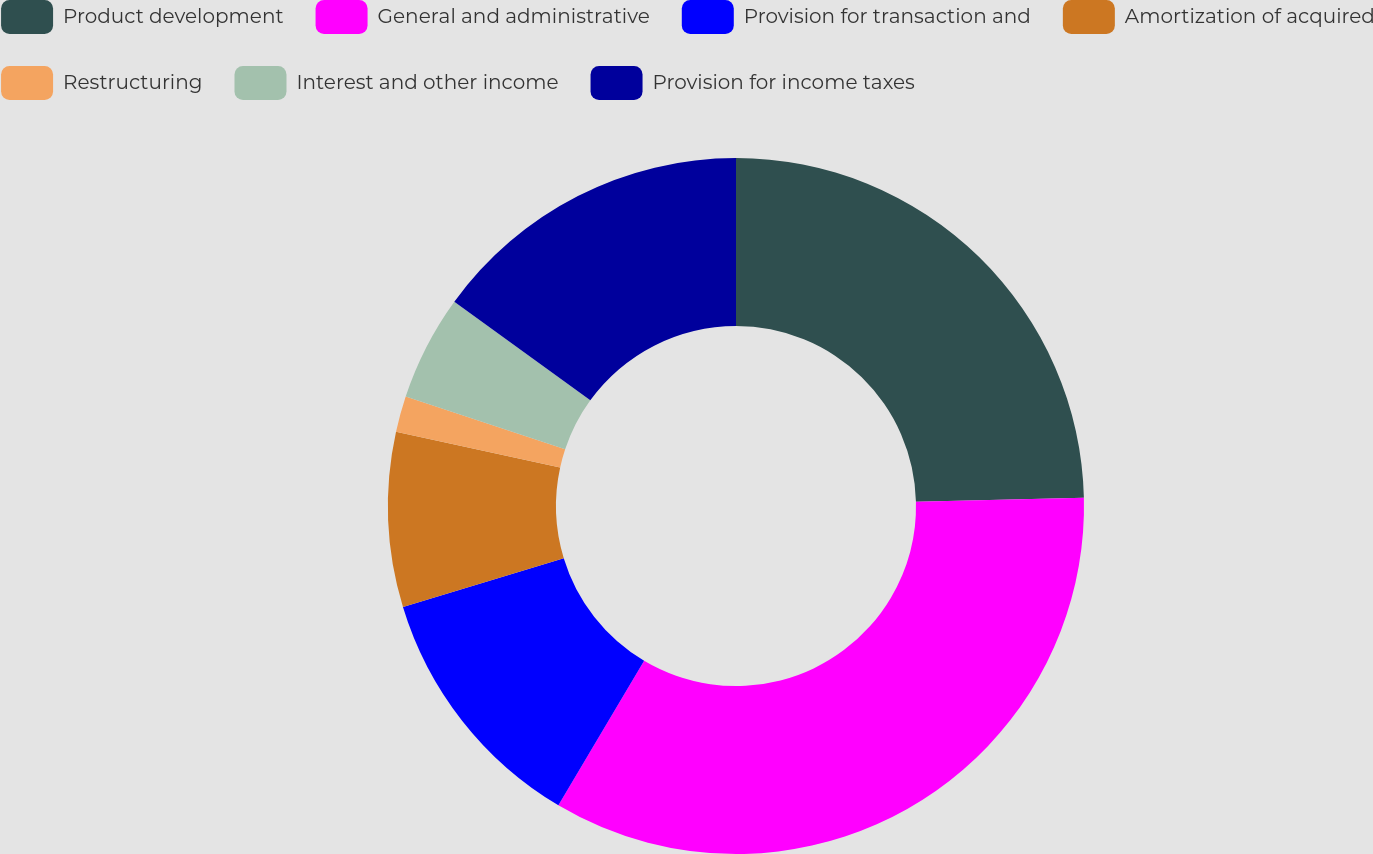Convert chart. <chart><loc_0><loc_0><loc_500><loc_500><pie_chart><fcel>Product development<fcel>General and administrative<fcel>Provision for transaction and<fcel>Amortization of acquired<fcel>Restructuring<fcel>Interest and other income<fcel>Provision for income taxes<nl><fcel>24.62%<fcel>33.9%<fcel>11.79%<fcel>8.11%<fcel>1.67%<fcel>4.89%<fcel>15.01%<nl></chart> 